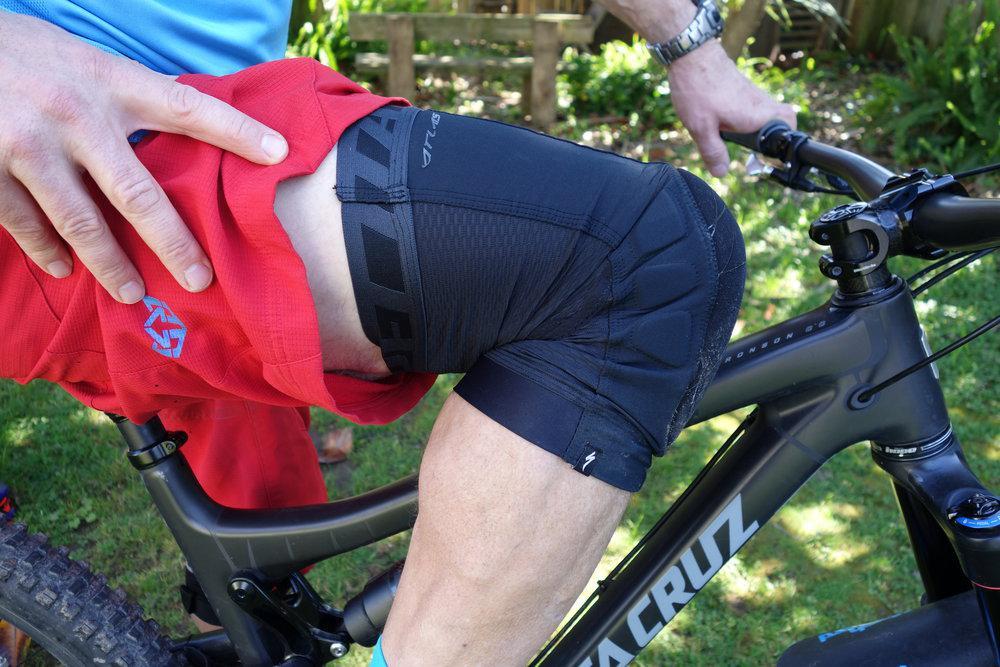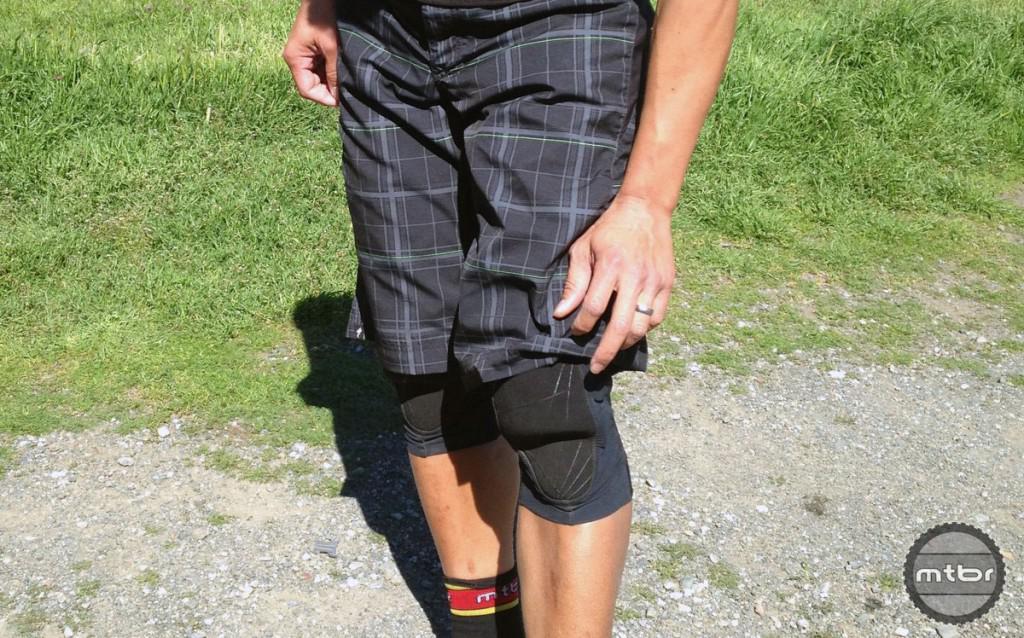The first image is the image on the left, the second image is the image on the right. For the images shown, is this caption "One of the knees in the image on the left is bent greater than ninety degrees." true? Answer yes or no. Yes. 